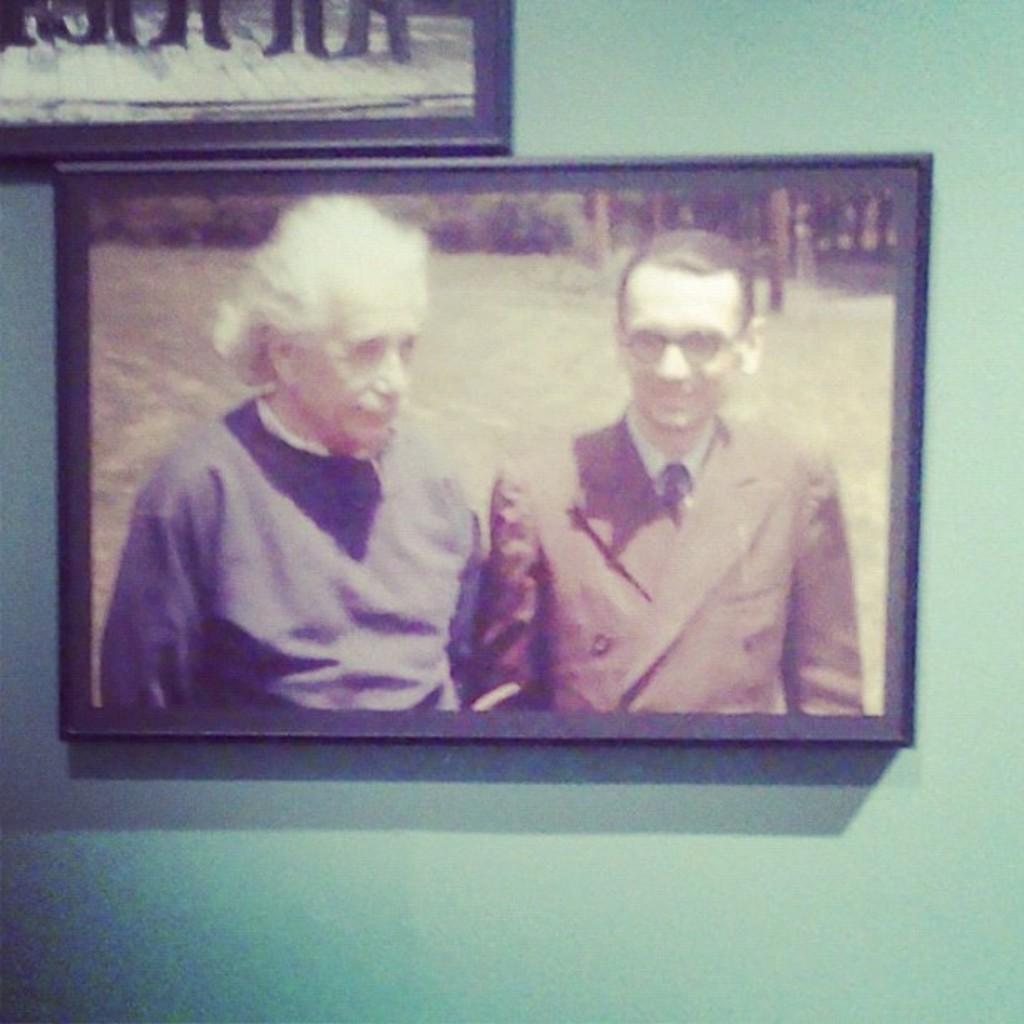Please provide a concise description of this image. In this image, there is a picture on the wall, in that picture there is Einstein and at the right side there is a man standing. 